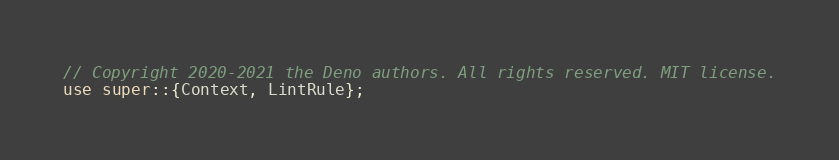<code> <loc_0><loc_0><loc_500><loc_500><_Rust_>// Copyright 2020-2021 the Deno authors. All rights reserved. MIT license.
use super::{Context, LintRule};</code> 